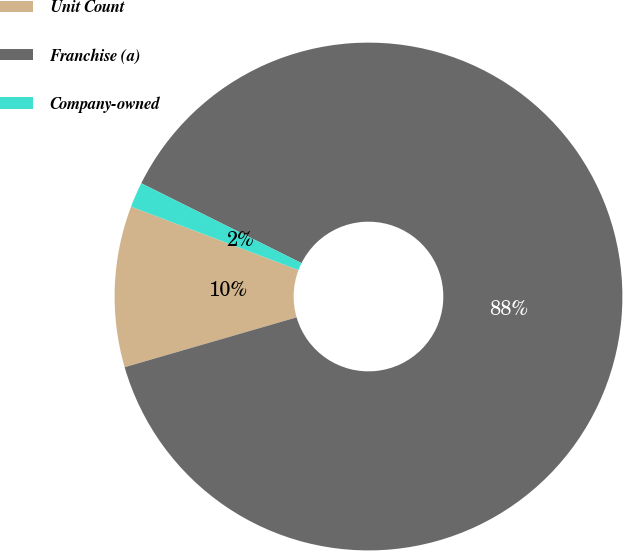<chart> <loc_0><loc_0><loc_500><loc_500><pie_chart><fcel>Unit Count<fcel>Franchise (a)<fcel>Company-owned<nl><fcel>10.25%<fcel>88.15%<fcel>1.6%<nl></chart> 